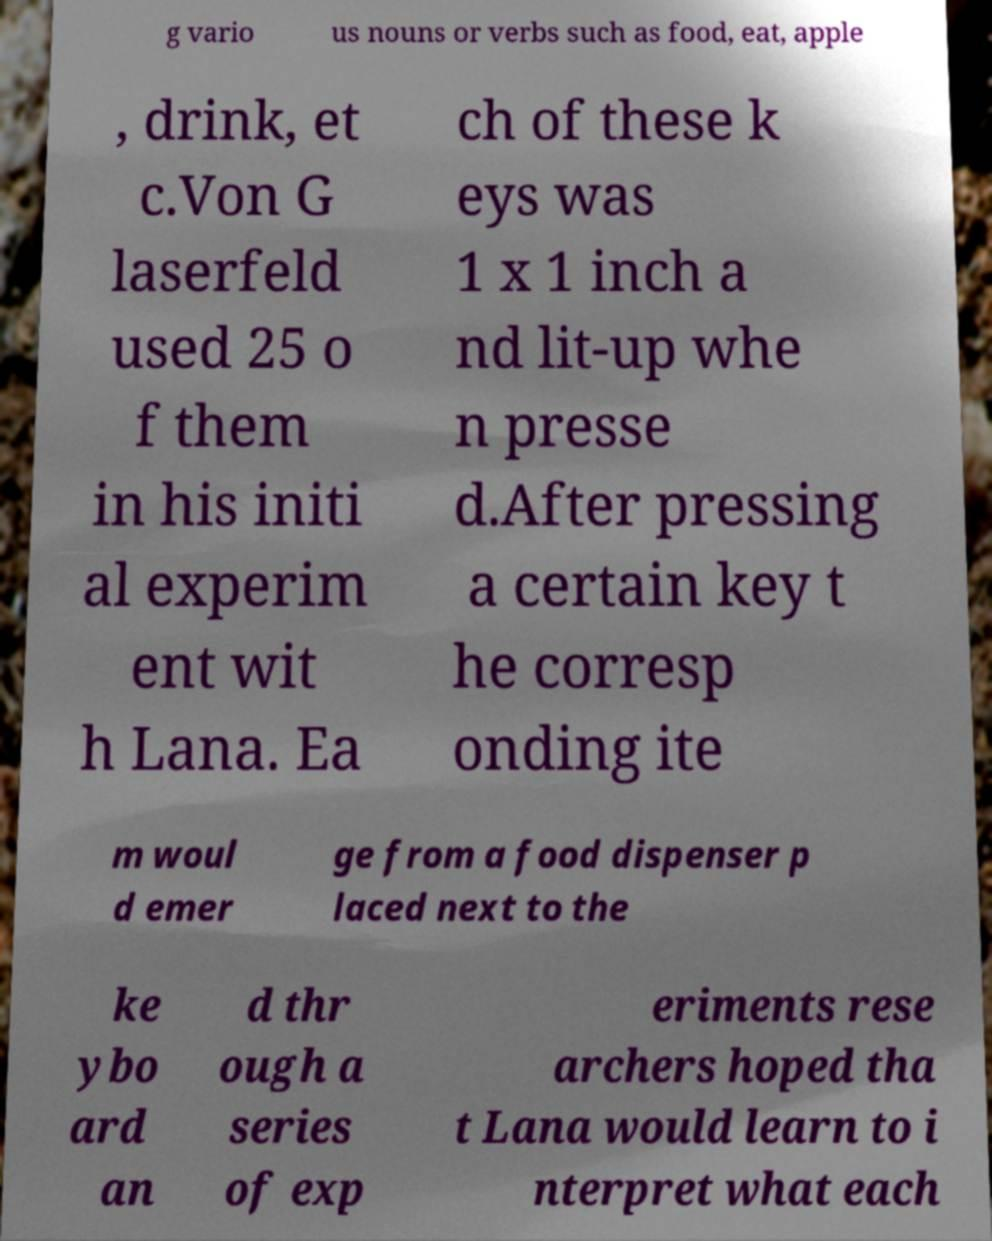For documentation purposes, I need the text within this image transcribed. Could you provide that? g vario us nouns or verbs such as food, eat, apple , drink, et c.Von G laserfeld used 25 o f them in his initi al experim ent wit h Lana. Ea ch of these k eys was 1 x 1 inch a nd lit-up whe n presse d.After pressing a certain key t he corresp onding ite m woul d emer ge from a food dispenser p laced next to the ke ybo ard an d thr ough a series of exp eriments rese archers hoped tha t Lana would learn to i nterpret what each 